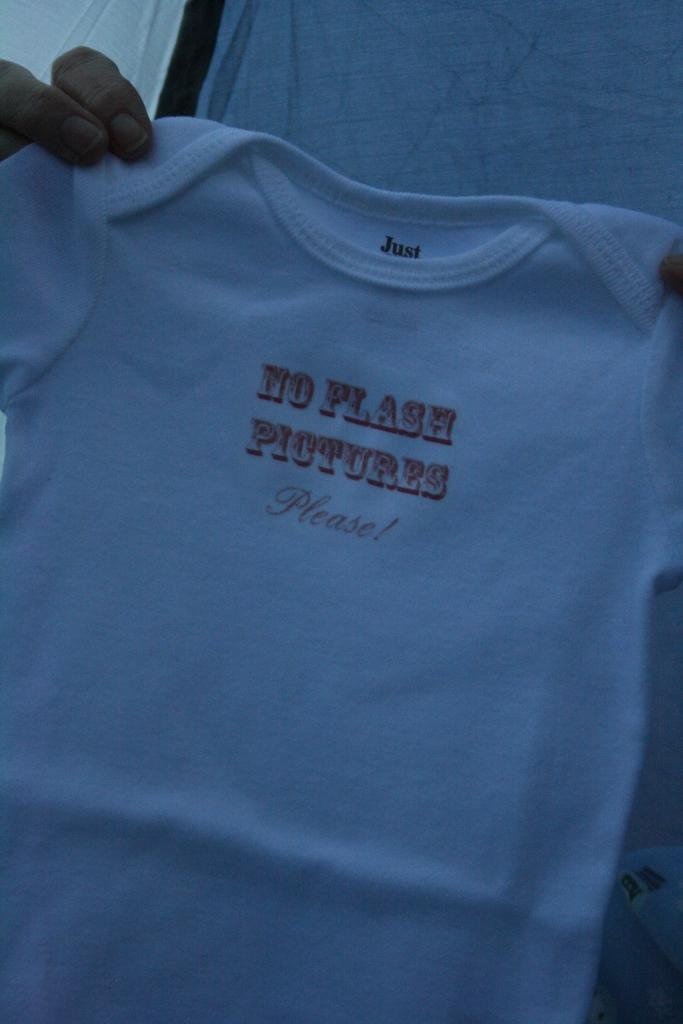<image>
Relay a brief, clear account of the picture shown. Someone holds baby clothing that says, "No Flash Pictures Please". 